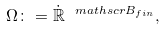Convert formula to latex. <formula><loc_0><loc_0><loc_500><loc_500>\Omega \colon = \dot { \mathbb { R } } ^ { \ m a t h s c r { B } _ { f i n } } ,</formula> 